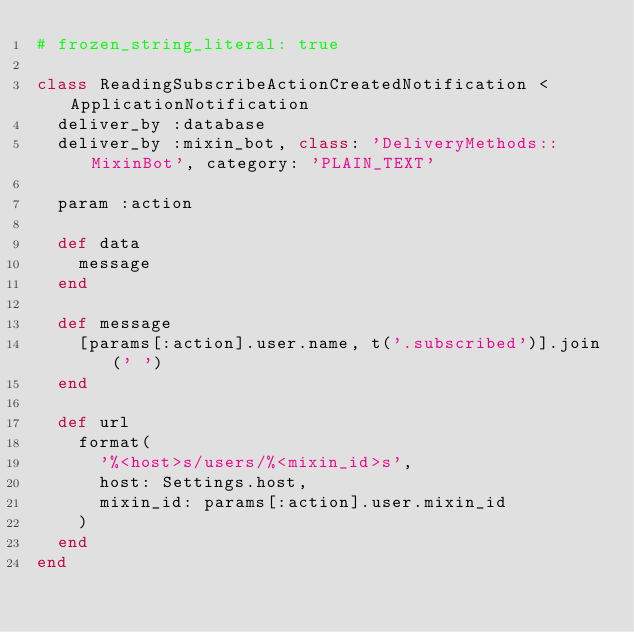Convert code to text. <code><loc_0><loc_0><loc_500><loc_500><_Ruby_># frozen_string_literal: true

class ReadingSubscribeActionCreatedNotification < ApplicationNotification
  deliver_by :database
  deliver_by :mixin_bot, class: 'DeliveryMethods::MixinBot', category: 'PLAIN_TEXT'

  param :action

  def data
    message
  end

  def message
    [params[:action].user.name, t('.subscribed')].join(' ')
  end

  def url
    format(
      '%<host>s/users/%<mixin_id>s',
      host: Settings.host,
      mixin_id: params[:action].user.mixin_id
    )
  end
end
</code> 